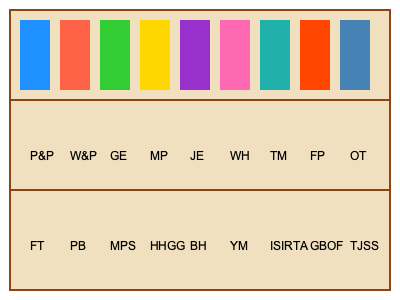Based on the bookshelf layout, which color represents the book that shares its initials with a famous British comedy sketch show featuring a dead parrot? To solve this puzzle, we need to follow these steps:

1. Identify the famous British comedy sketch show featuring a dead parrot:
   This is a reference to Monty Python's "Dead Parrot Sketch" from the show "Monty Python's Flying Circus."

2. Look for the initials that match "Monty Python's Flying Circus" on the bookshelf:
   Scanning the bottom row, we find "MPS" which likely stands for "Monty Python Scripts."

3. Locate the position of "MPS" on the bookshelf:
   "MPS" is in the third position from the left on the bottom row.

4. Find the corresponding book color in the top row:
   The book directly above "MPS" in the top row is colored green.

Therefore, the color that represents the book sharing its initials with the famous British comedy show featuring a dead parrot sketch is green.
Answer: Green 